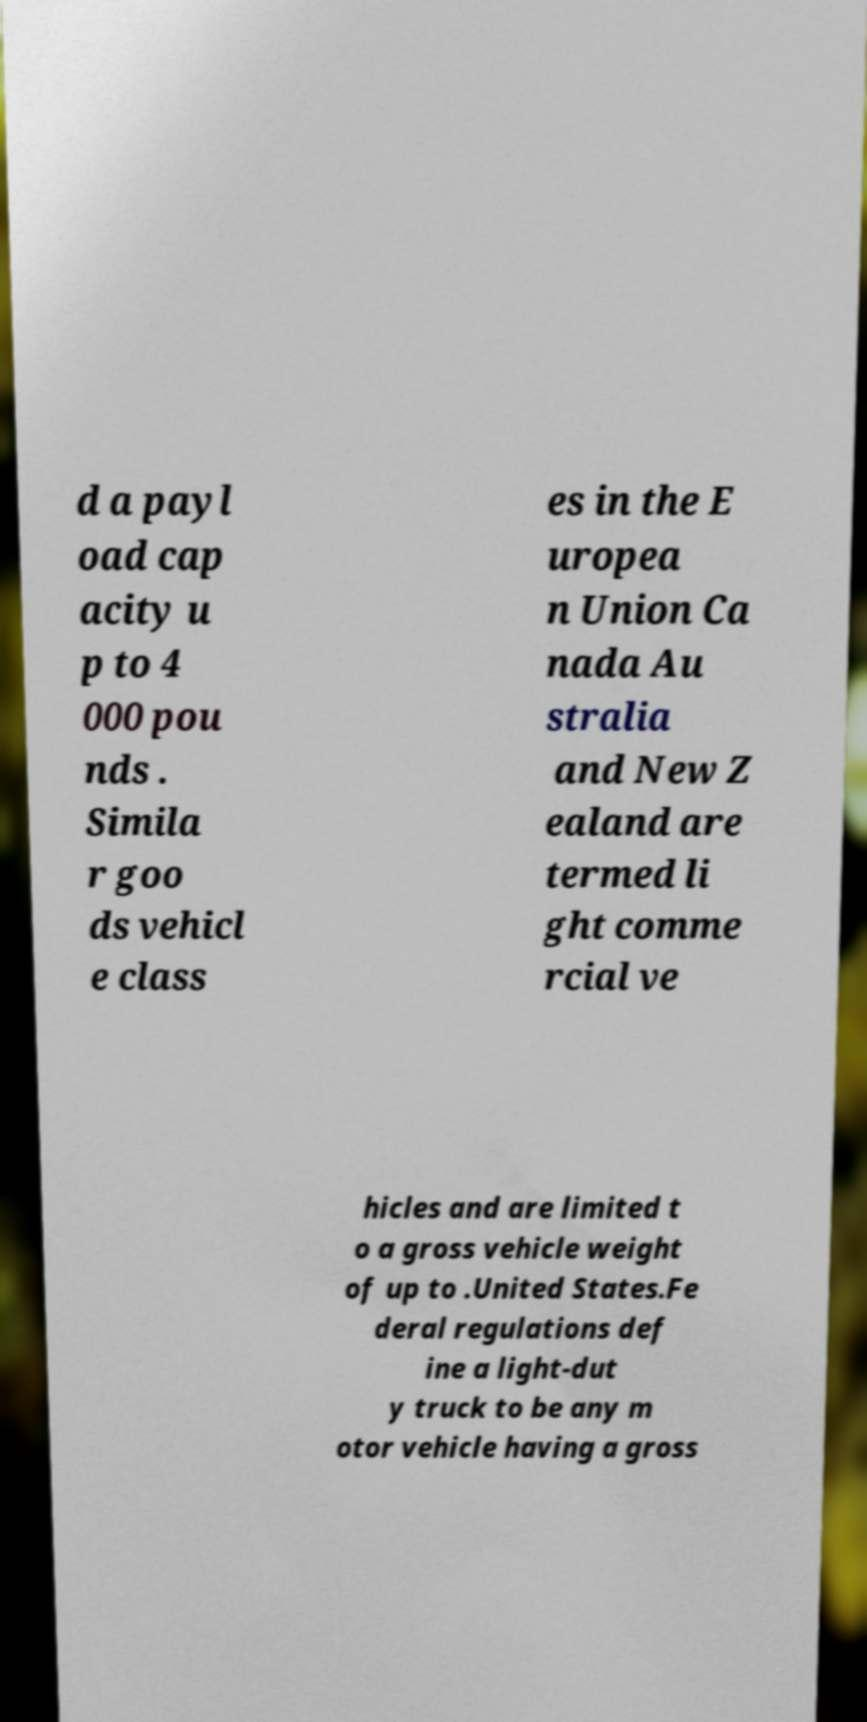Can you read and provide the text displayed in the image?This photo seems to have some interesting text. Can you extract and type it out for me? d a payl oad cap acity u p to 4 000 pou nds . Simila r goo ds vehicl e class es in the E uropea n Union Ca nada Au stralia and New Z ealand are termed li ght comme rcial ve hicles and are limited t o a gross vehicle weight of up to .United States.Fe deral regulations def ine a light-dut y truck to be any m otor vehicle having a gross 